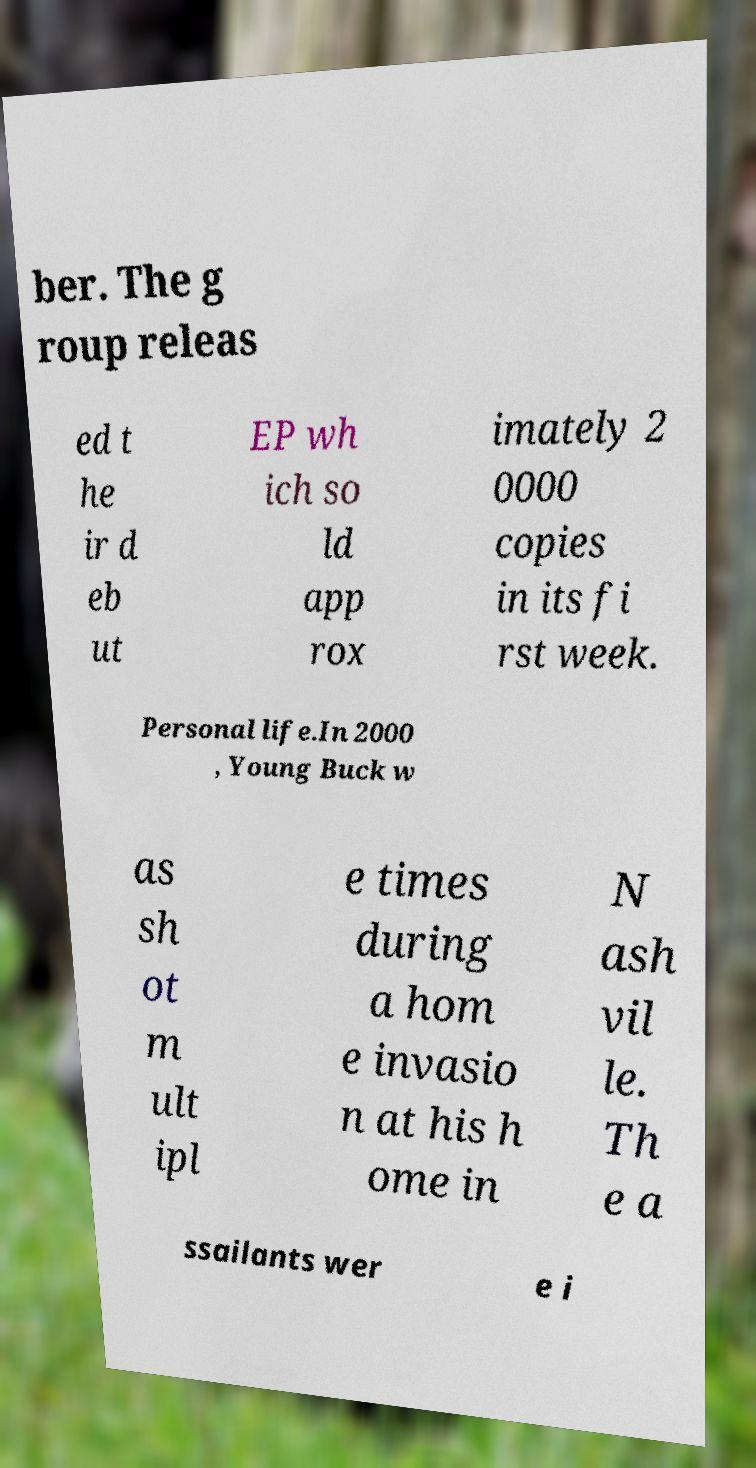Can you accurately transcribe the text from the provided image for me? ber. The g roup releas ed t he ir d eb ut EP wh ich so ld app rox imately 2 0000 copies in its fi rst week. Personal life.In 2000 , Young Buck w as sh ot m ult ipl e times during a hom e invasio n at his h ome in N ash vil le. Th e a ssailants wer e i 